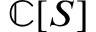<formula> <loc_0><loc_0><loc_500><loc_500>\mathbb { C } [ S ]</formula> 